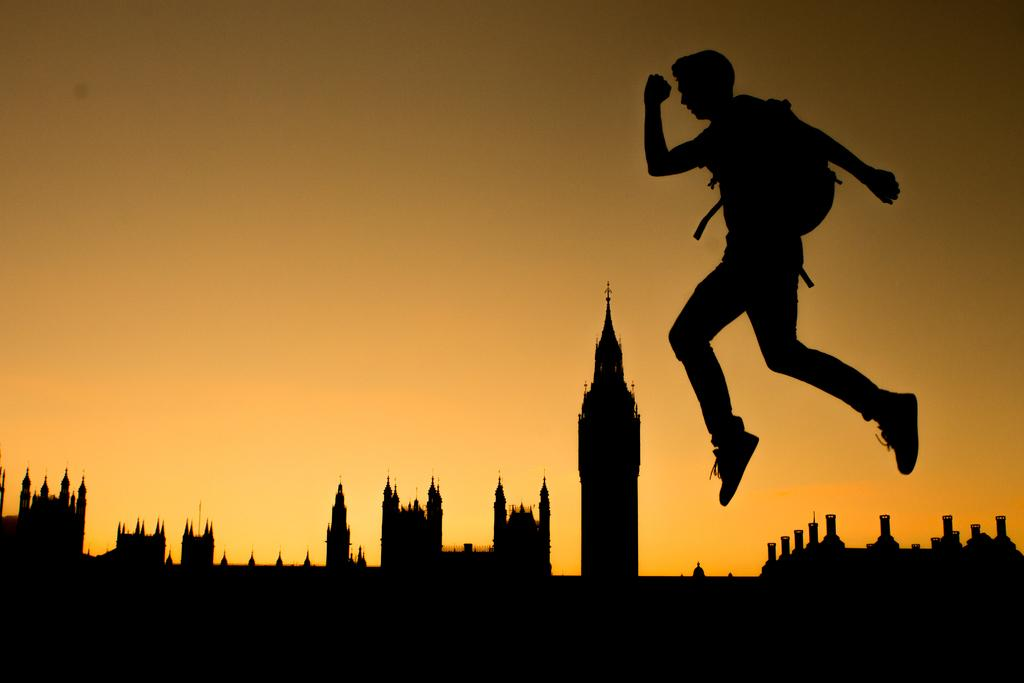Who is the main subject in the image? There is a man in the image. What is the man doing in the image? The man is running in the image. How high is the man in the image? The man is in the air in the image. What is the man wearing in the image? The man is wearing a bag in the image. What can be seen in the background of the image? There is a sky in the background of the image. What is at the bottom of the image? There are monuments at the bottom of the image. What type of banana is the man holding in the image? There is no banana present in the image. How many men are visible in the image? There is only one man visible in the image. 